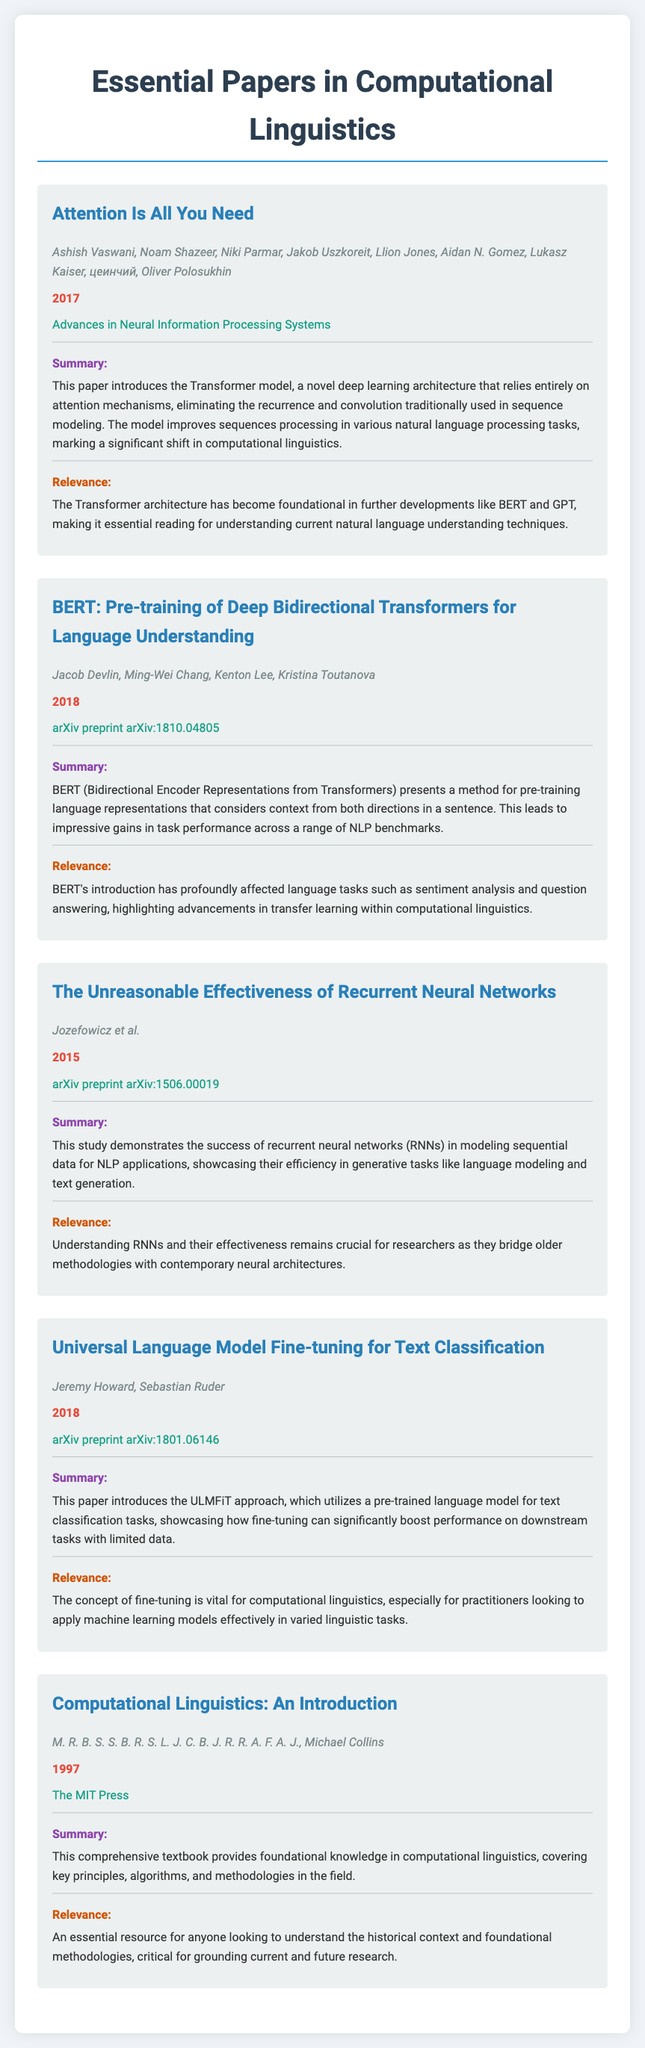What is the title of the first paper? The title of the first paper is located at the top of the section for the first entry in the document.
Answer: Attention Is All You Need Who are the authors of BERT? The authors of BERT are listed right below the title in the corresponding section.
Answer: Jacob Devlin, Ming-Wei Chang, Kenton Lee, Kristina Toutanova In what year was the Transformer model introduced? The year is noted prominently under the title of the paper discussing the Transformer model.
Answer: 2017 What area of research does the paper "Universal Language Model Fine-tuning for Text Classification" focus on? This information can be found in the summary section of the respective paper.
Answer: Text Classification Which paper discusses recurrent neural networks? This is identifiable by the title of the paper that specifically mentions RNNs.
Answer: The Unreasonable Effectiveness of Recurrent Neural Networks What journal published the introduction to computational linguistics? The journal name is specified under the year for the corresponding paper.
Answer: The MIT Press How many authors contributed to the paper "Attention Is All You Need"? The number of authors is counted from the list provided in the author section of that paper.
Answer: 8 What significant shift does the paper on the Transformer model mention? This concept is part of the summary that discusses the impact of the model.
Answer: A significant shift in computational linguistics What foundational concept is highlighted in "Universal Language Model Fine-tuning for Text Classification"? This can be understood from the relevance section, which mentions its practicality in the field.
Answer: Fine-tuning 